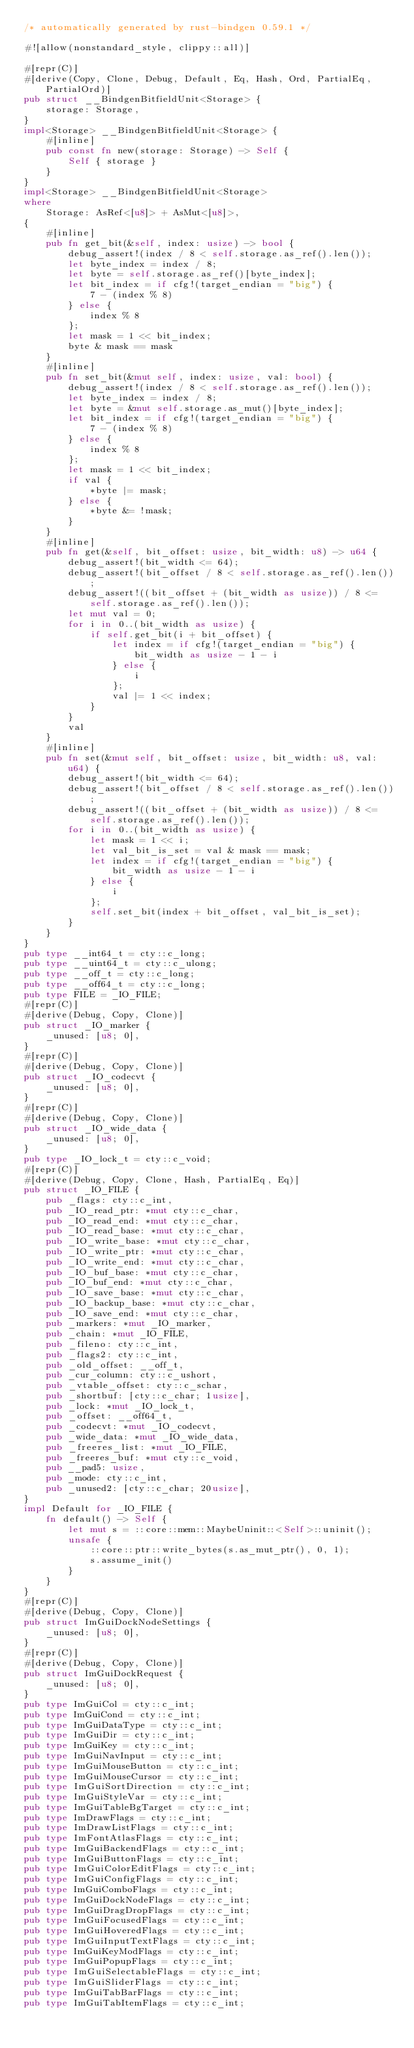<code> <loc_0><loc_0><loc_500><loc_500><_Rust_>/* automatically generated by rust-bindgen 0.59.1 */

#![allow(nonstandard_style, clippy::all)]

#[repr(C)]
#[derive(Copy, Clone, Debug, Default, Eq, Hash, Ord, PartialEq, PartialOrd)]
pub struct __BindgenBitfieldUnit<Storage> {
    storage: Storage,
}
impl<Storage> __BindgenBitfieldUnit<Storage> {
    #[inline]
    pub const fn new(storage: Storage) -> Self {
        Self { storage }
    }
}
impl<Storage> __BindgenBitfieldUnit<Storage>
where
    Storage: AsRef<[u8]> + AsMut<[u8]>,
{
    #[inline]
    pub fn get_bit(&self, index: usize) -> bool {
        debug_assert!(index / 8 < self.storage.as_ref().len());
        let byte_index = index / 8;
        let byte = self.storage.as_ref()[byte_index];
        let bit_index = if cfg!(target_endian = "big") {
            7 - (index % 8)
        } else {
            index % 8
        };
        let mask = 1 << bit_index;
        byte & mask == mask
    }
    #[inline]
    pub fn set_bit(&mut self, index: usize, val: bool) {
        debug_assert!(index / 8 < self.storage.as_ref().len());
        let byte_index = index / 8;
        let byte = &mut self.storage.as_mut()[byte_index];
        let bit_index = if cfg!(target_endian = "big") {
            7 - (index % 8)
        } else {
            index % 8
        };
        let mask = 1 << bit_index;
        if val {
            *byte |= mask;
        } else {
            *byte &= !mask;
        }
    }
    #[inline]
    pub fn get(&self, bit_offset: usize, bit_width: u8) -> u64 {
        debug_assert!(bit_width <= 64);
        debug_assert!(bit_offset / 8 < self.storage.as_ref().len());
        debug_assert!((bit_offset + (bit_width as usize)) / 8 <= self.storage.as_ref().len());
        let mut val = 0;
        for i in 0..(bit_width as usize) {
            if self.get_bit(i + bit_offset) {
                let index = if cfg!(target_endian = "big") {
                    bit_width as usize - 1 - i
                } else {
                    i
                };
                val |= 1 << index;
            }
        }
        val
    }
    #[inline]
    pub fn set(&mut self, bit_offset: usize, bit_width: u8, val: u64) {
        debug_assert!(bit_width <= 64);
        debug_assert!(bit_offset / 8 < self.storage.as_ref().len());
        debug_assert!((bit_offset + (bit_width as usize)) / 8 <= self.storage.as_ref().len());
        for i in 0..(bit_width as usize) {
            let mask = 1 << i;
            let val_bit_is_set = val & mask == mask;
            let index = if cfg!(target_endian = "big") {
                bit_width as usize - 1 - i
            } else {
                i
            };
            self.set_bit(index + bit_offset, val_bit_is_set);
        }
    }
}
pub type __int64_t = cty::c_long;
pub type __uint64_t = cty::c_ulong;
pub type __off_t = cty::c_long;
pub type __off64_t = cty::c_long;
pub type FILE = _IO_FILE;
#[repr(C)]
#[derive(Debug, Copy, Clone)]
pub struct _IO_marker {
    _unused: [u8; 0],
}
#[repr(C)]
#[derive(Debug, Copy, Clone)]
pub struct _IO_codecvt {
    _unused: [u8; 0],
}
#[repr(C)]
#[derive(Debug, Copy, Clone)]
pub struct _IO_wide_data {
    _unused: [u8; 0],
}
pub type _IO_lock_t = cty::c_void;
#[repr(C)]
#[derive(Debug, Copy, Clone, Hash, PartialEq, Eq)]
pub struct _IO_FILE {
    pub _flags: cty::c_int,
    pub _IO_read_ptr: *mut cty::c_char,
    pub _IO_read_end: *mut cty::c_char,
    pub _IO_read_base: *mut cty::c_char,
    pub _IO_write_base: *mut cty::c_char,
    pub _IO_write_ptr: *mut cty::c_char,
    pub _IO_write_end: *mut cty::c_char,
    pub _IO_buf_base: *mut cty::c_char,
    pub _IO_buf_end: *mut cty::c_char,
    pub _IO_save_base: *mut cty::c_char,
    pub _IO_backup_base: *mut cty::c_char,
    pub _IO_save_end: *mut cty::c_char,
    pub _markers: *mut _IO_marker,
    pub _chain: *mut _IO_FILE,
    pub _fileno: cty::c_int,
    pub _flags2: cty::c_int,
    pub _old_offset: __off_t,
    pub _cur_column: cty::c_ushort,
    pub _vtable_offset: cty::c_schar,
    pub _shortbuf: [cty::c_char; 1usize],
    pub _lock: *mut _IO_lock_t,
    pub _offset: __off64_t,
    pub _codecvt: *mut _IO_codecvt,
    pub _wide_data: *mut _IO_wide_data,
    pub _freeres_list: *mut _IO_FILE,
    pub _freeres_buf: *mut cty::c_void,
    pub __pad5: usize,
    pub _mode: cty::c_int,
    pub _unused2: [cty::c_char; 20usize],
}
impl Default for _IO_FILE {
    fn default() -> Self {
        let mut s = ::core::mem::MaybeUninit::<Self>::uninit();
        unsafe {
            ::core::ptr::write_bytes(s.as_mut_ptr(), 0, 1);
            s.assume_init()
        }
    }
}
#[repr(C)]
#[derive(Debug, Copy, Clone)]
pub struct ImGuiDockNodeSettings {
    _unused: [u8; 0],
}
#[repr(C)]
#[derive(Debug, Copy, Clone)]
pub struct ImGuiDockRequest {
    _unused: [u8; 0],
}
pub type ImGuiCol = cty::c_int;
pub type ImGuiCond = cty::c_int;
pub type ImGuiDataType = cty::c_int;
pub type ImGuiDir = cty::c_int;
pub type ImGuiKey = cty::c_int;
pub type ImGuiNavInput = cty::c_int;
pub type ImGuiMouseButton = cty::c_int;
pub type ImGuiMouseCursor = cty::c_int;
pub type ImGuiSortDirection = cty::c_int;
pub type ImGuiStyleVar = cty::c_int;
pub type ImGuiTableBgTarget = cty::c_int;
pub type ImDrawFlags = cty::c_int;
pub type ImDrawListFlags = cty::c_int;
pub type ImFontAtlasFlags = cty::c_int;
pub type ImGuiBackendFlags = cty::c_int;
pub type ImGuiButtonFlags = cty::c_int;
pub type ImGuiColorEditFlags = cty::c_int;
pub type ImGuiConfigFlags = cty::c_int;
pub type ImGuiComboFlags = cty::c_int;
pub type ImGuiDockNodeFlags = cty::c_int;
pub type ImGuiDragDropFlags = cty::c_int;
pub type ImGuiFocusedFlags = cty::c_int;
pub type ImGuiHoveredFlags = cty::c_int;
pub type ImGuiInputTextFlags = cty::c_int;
pub type ImGuiKeyModFlags = cty::c_int;
pub type ImGuiPopupFlags = cty::c_int;
pub type ImGuiSelectableFlags = cty::c_int;
pub type ImGuiSliderFlags = cty::c_int;
pub type ImGuiTabBarFlags = cty::c_int;
pub type ImGuiTabItemFlags = cty::c_int;</code> 